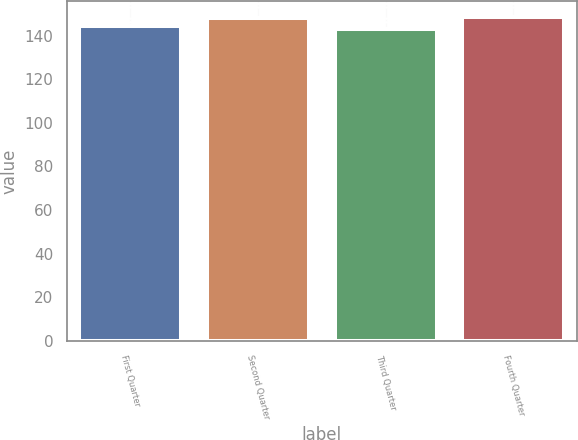<chart> <loc_0><loc_0><loc_500><loc_500><bar_chart><fcel>First Quarter<fcel>Second Quarter<fcel>Third Quarter<fcel>Fourth Quarter<nl><fcel>144.69<fcel>148<fcel>143.18<fcel>148.51<nl></chart> 